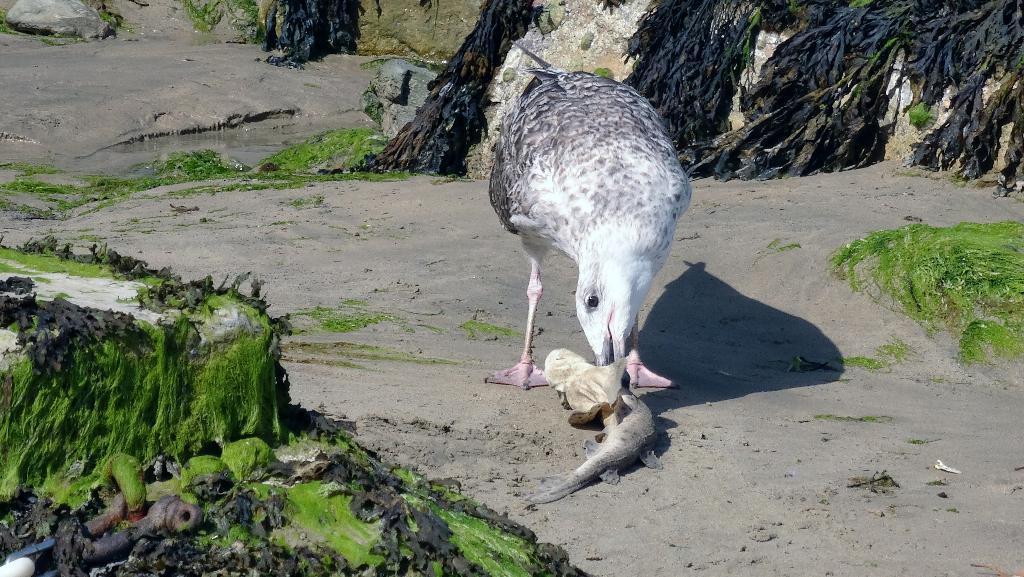Can you describe this image briefly? In the center of the image we can see a bird is eating a fish. In the background of the image we can see the rocks, algae, mud, water. 